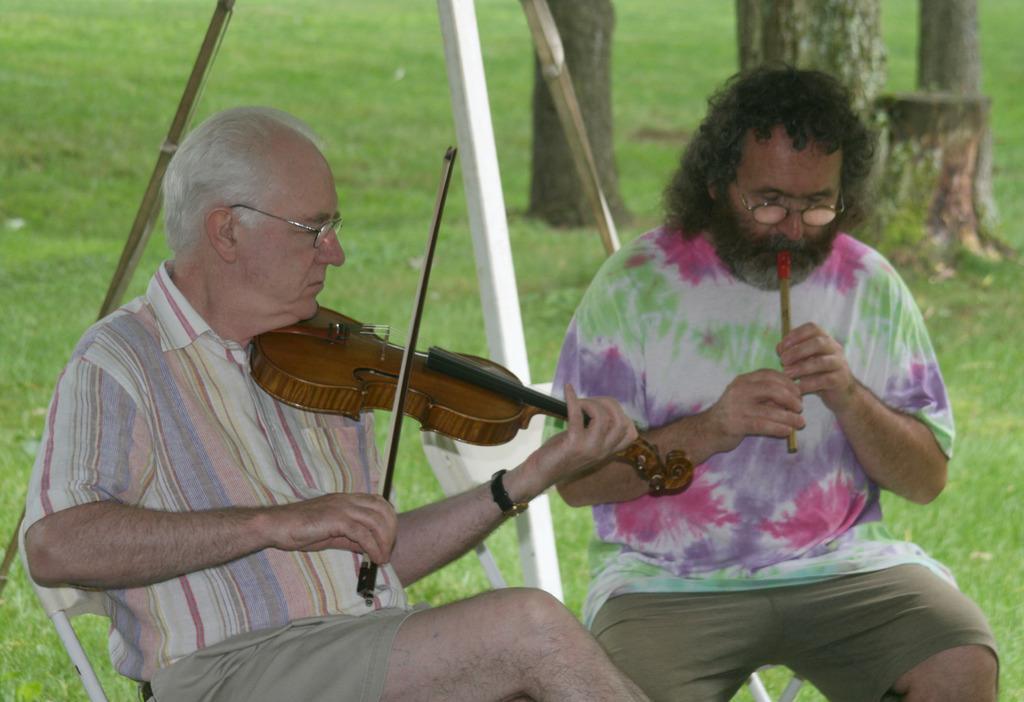Please provide a concise description of this image. In the image we can see there are people sitting on the chair and they are playing musical instruments. The ground is covered with grass. 